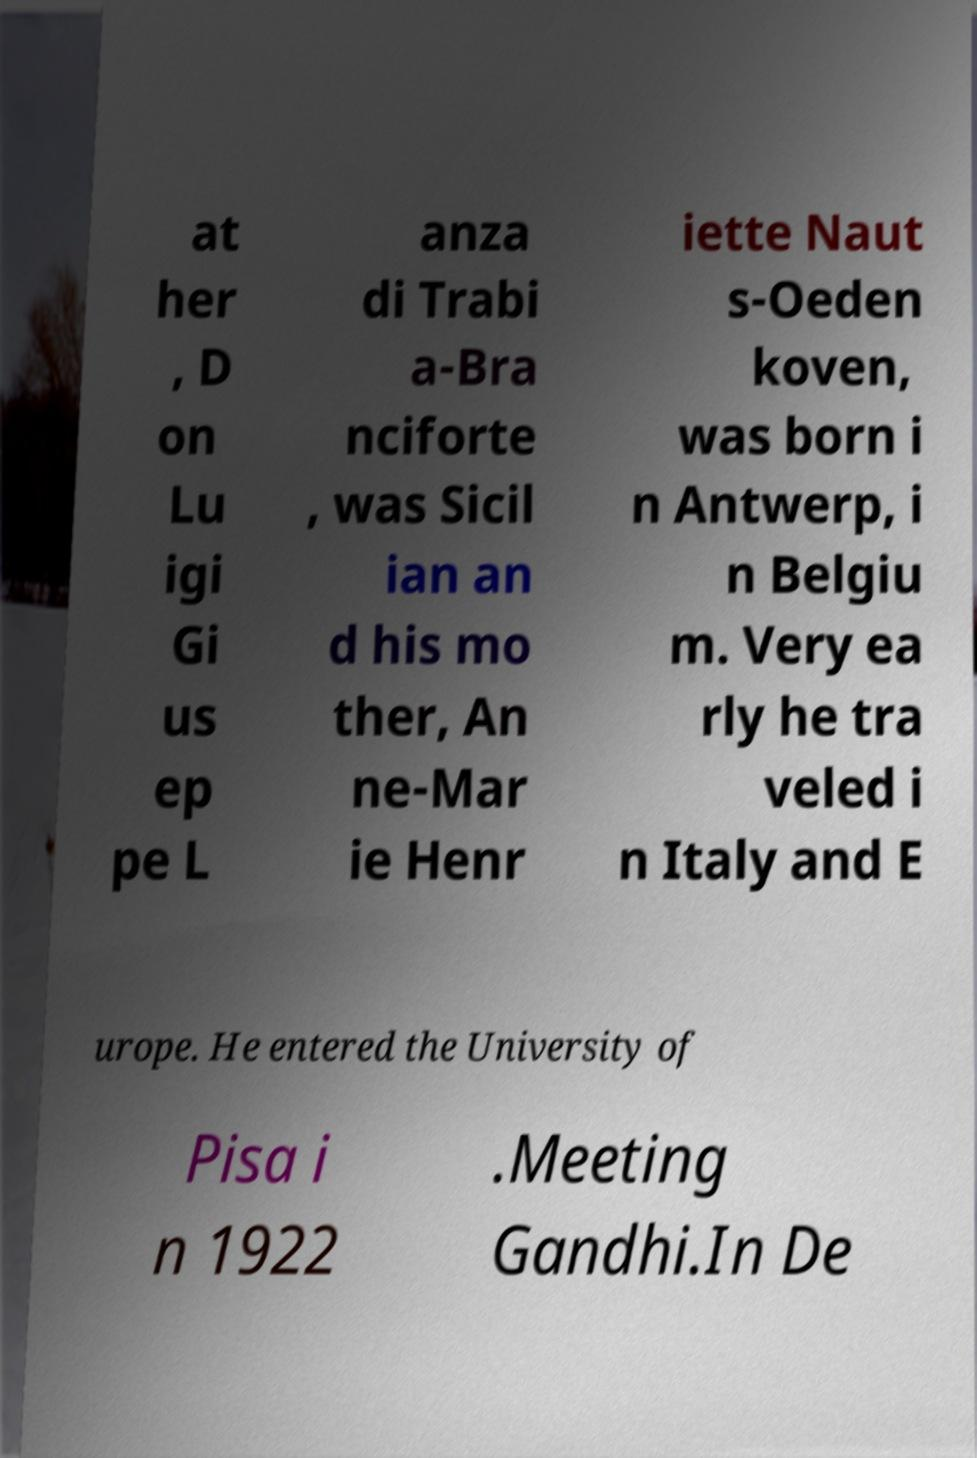Can you read and provide the text displayed in the image?This photo seems to have some interesting text. Can you extract and type it out for me? at her , D on Lu igi Gi us ep pe L anza di Trabi a-Bra nciforte , was Sicil ian an d his mo ther, An ne-Mar ie Henr iette Naut s-Oeden koven, was born i n Antwerp, i n Belgiu m. Very ea rly he tra veled i n Italy and E urope. He entered the University of Pisa i n 1922 .Meeting Gandhi.In De 